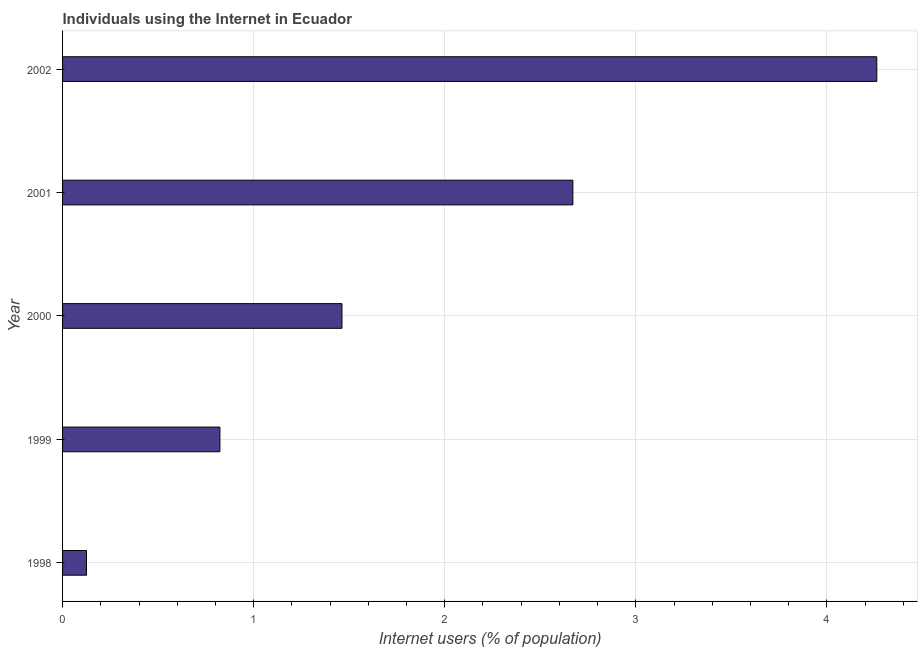Does the graph contain any zero values?
Provide a succinct answer. No. Does the graph contain grids?
Ensure brevity in your answer.  Yes. What is the title of the graph?
Provide a short and direct response. Individuals using the Internet in Ecuador. What is the label or title of the X-axis?
Provide a succinct answer. Internet users (% of population). What is the number of internet users in 1998?
Your answer should be compact. 0.13. Across all years, what is the maximum number of internet users?
Make the answer very short. 4.26. Across all years, what is the minimum number of internet users?
Offer a very short reply. 0.13. What is the sum of the number of internet users?
Your answer should be very brief. 9.34. What is the difference between the number of internet users in 1998 and 2000?
Provide a short and direct response. -1.34. What is the average number of internet users per year?
Your answer should be very brief. 1.87. What is the median number of internet users?
Keep it short and to the point. 1.46. In how many years, is the number of internet users greater than 0.6 %?
Your answer should be compact. 4. What is the ratio of the number of internet users in 2000 to that in 2002?
Offer a terse response. 0.34. Is the difference between the number of internet users in 1998 and 1999 greater than the difference between any two years?
Ensure brevity in your answer.  No. What is the difference between the highest and the second highest number of internet users?
Make the answer very short. 1.59. What is the difference between the highest and the lowest number of internet users?
Make the answer very short. 4.14. In how many years, is the number of internet users greater than the average number of internet users taken over all years?
Your answer should be compact. 2. Are all the bars in the graph horizontal?
Provide a short and direct response. Yes. How many years are there in the graph?
Your answer should be very brief. 5. What is the Internet users (% of population) in 1998?
Your answer should be compact. 0.13. What is the Internet users (% of population) in 1999?
Offer a very short reply. 0.82. What is the Internet users (% of population) in 2000?
Give a very brief answer. 1.46. What is the Internet users (% of population) of 2001?
Keep it short and to the point. 2.67. What is the Internet users (% of population) in 2002?
Your answer should be very brief. 4.26. What is the difference between the Internet users (% of population) in 1998 and 1999?
Provide a succinct answer. -0.7. What is the difference between the Internet users (% of population) in 1998 and 2000?
Make the answer very short. -1.34. What is the difference between the Internet users (% of population) in 1998 and 2001?
Provide a short and direct response. -2.55. What is the difference between the Internet users (% of population) in 1998 and 2002?
Provide a succinct answer. -4.14. What is the difference between the Internet users (% of population) in 1999 and 2000?
Keep it short and to the point. -0.64. What is the difference between the Internet users (% of population) in 1999 and 2001?
Make the answer very short. -1.85. What is the difference between the Internet users (% of population) in 1999 and 2002?
Offer a very short reply. -3.44. What is the difference between the Internet users (% of population) in 2000 and 2001?
Your answer should be compact. -1.21. What is the difference between the Internet users (% of population) in 2000 and 2002?
Your answer should be very brief. -2.8. What is the difference between the Internet users (% of population) in 2001 and 2002?
Provide a succinct answer. -1.59. What is the ratio of the Internet users (% of population) in 1998 to that in 1999?
Your response must be concise. 0.15. What is the ratio of the Internet users (% of population) in 1998 to that in 2000?
Your answer should be very brief. 0.09. What is the ratio of the Internet users (% of population) in 1998 to that in 2001?
Your answer should be compact. 0.05. What is the ratio of the Internet users (% of population) in 1998 to that in 2002?
Your answer should be very brief. 0.03. What is the ratio of the Internet users (% of population) in 1999 to that in 2000?
Keep it short and to the point. 0.56. What is the ratio of the Internet users (% of population) in 1999 to that in 2001?
Provide a succinct answer. 0.31. What is the ratio of the Internet users (% of population) in 1999 to that in 2002?
Provide a short and direct response. 0.19. What is the ratio of the Internet users (% of population) in 2000 to that in 2001?
Provide a short and direct response. 0.55. What is the ratio of the Internet users (% of population) in 2000 to that in 2002?
Ensure brevity in your answer.  0.34. What is the ratio of the Internet users (% of population) in 2001 to that in 2002?
Offer a terse response. 0.63. 